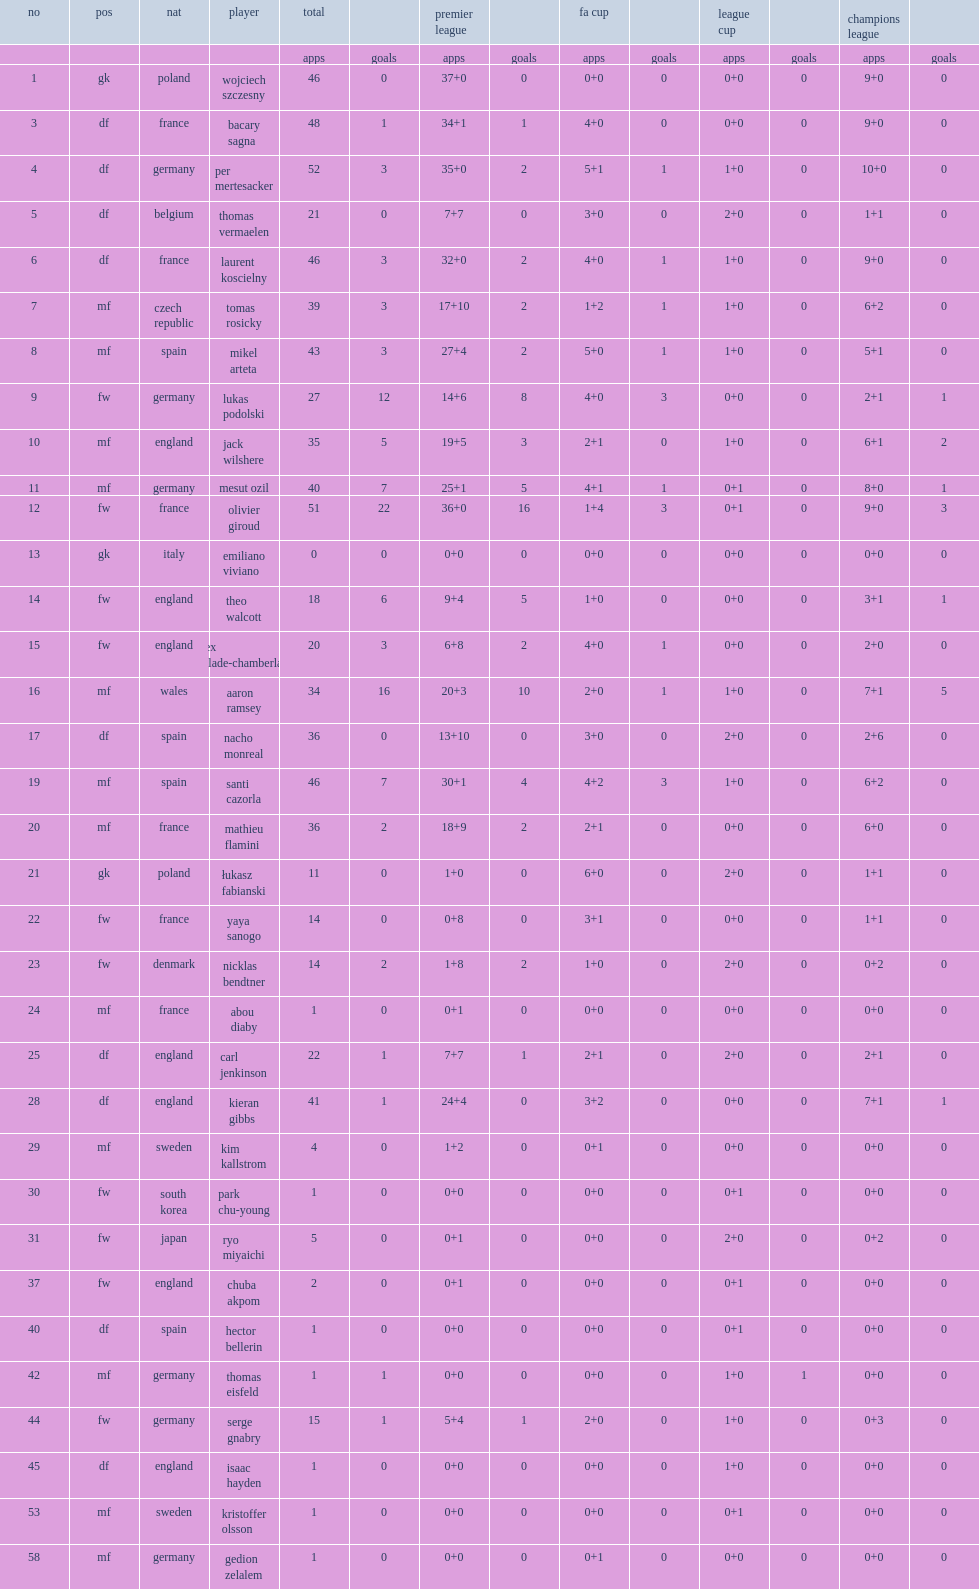List the matches that arsenal participated in. Premier league fa cup league cup champions league. 